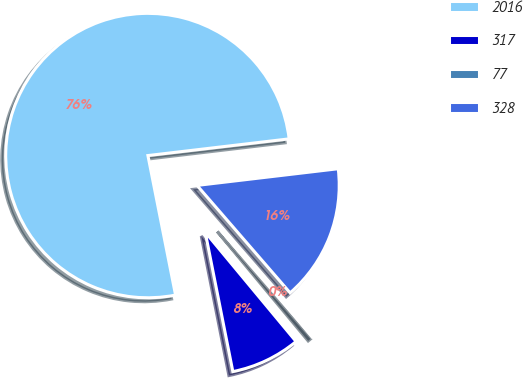Convert chart. <chart><loc_0><loc_0><loc_500><loc_500><pie_chart><fcel>2016<fcel>317<fcel>77<fcel>328<nl><fcel>76.24%<fcel>7.92%<fcel>0.33%<fcel>15.51%<nl></chart> 